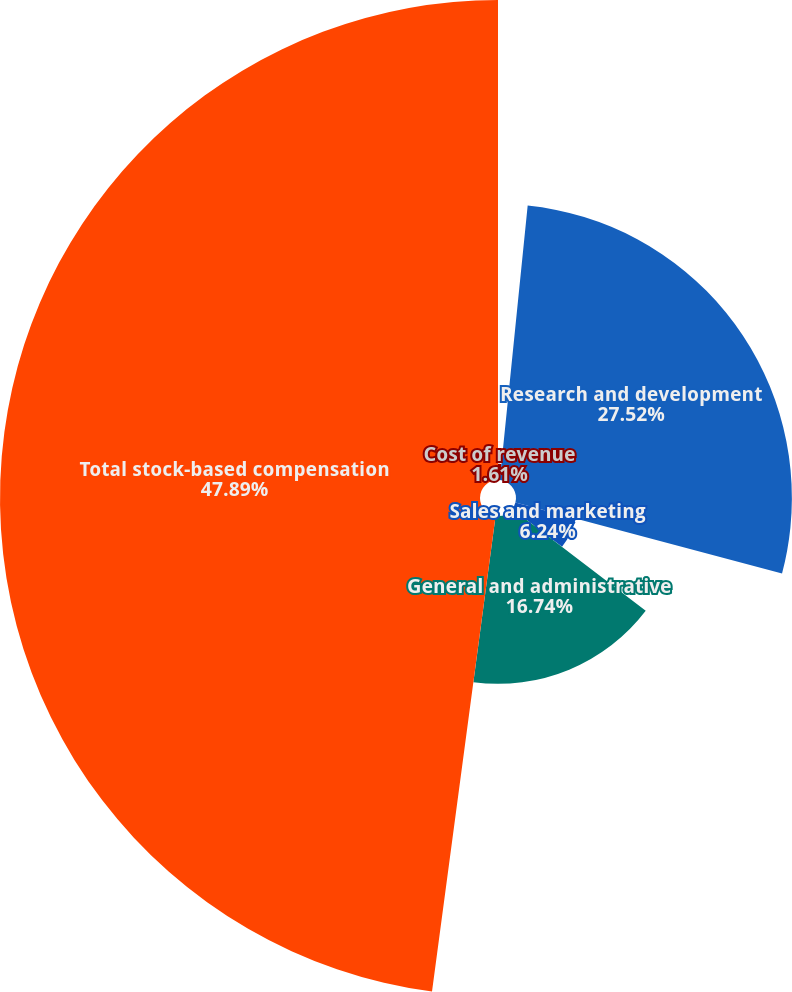Convert chart. <chart><loc_0><loc_0><loc_500><loc_500><pie_chart><fcel>Cost of revenue<fcel>Research and development<fcel>Sales and marketing<fcel>General and administrative<fcel>Total stock-based compensation<nl><fcel>1.61%<fcel>27.52%<fcel>6.24%<fcel>16.74%<fcel>47.88%<nl></chart> 